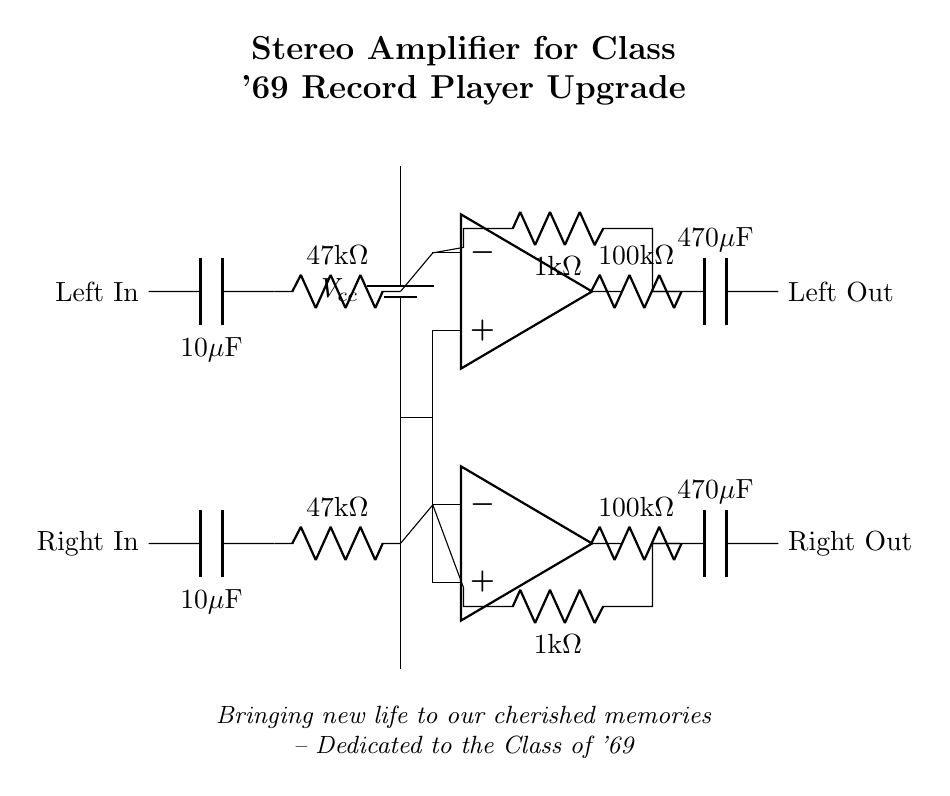What is the value of the input resistors? The diagram indicates that both the left and right input resistors are labeled as 47kΩ, meaning each has a resistance of 47,000 ohms.
Answer: 47kΩ What is the capacitance value of the coupling capacitors? The coupling capacitors for both channels are labeled as 10μF, indicating each capacitor can hold 10 microfarads of charge.
Answer: 10μF What type of amplifier is depicted in the circuit? The circuit uses operational amplifiers, which are identified in the diagram as op amps. These amplifiers are commonly used in audio applications.
Answer: Operational Amplifiers How many output capacitors are in the circuit? By inspecting the diagram, we can see two output capacitors, one for each channel (left and right), labeled as 470μF.
Answer: 2 What is the value of the feedback resistors for the amplifiers? Both feedback resistors for each amplifier stage are labeled as 100kΩ, indicating they have a resistance of 100,000 ohms.
Answer: 100kΩ What is the purpose of the 470μF capacitors at the output? The 470μF capacitors at the output serve to block any DC component and allow only AC signals to pass, ensuring that the audio output is clean and suitable for speakers.
Answer: Block DC What is the overall purpose of this circuit? The overall purpose of this circuit is to amplify the audio signals from a record player to drive speakers, enhancing the sound output quality for an upgraded listening experience.
Answer: Amplify audio signals 